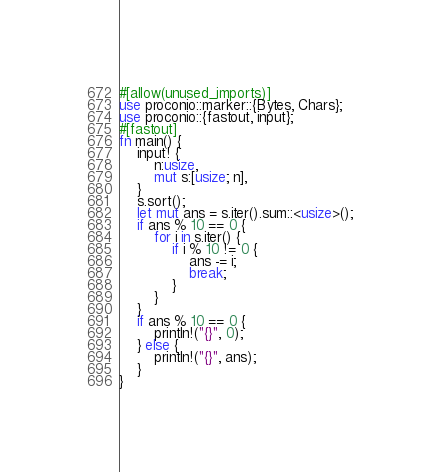<code> <loc_0><loc_0><loc_500><loc_500><_Rust_>#[allow(unused_imports)]
use proconio::marker::{Bytes, Chars};
use proconio::{fastout, input};
#[fastout]
fn main() {
    input! {
        n:usize,
        mut s:[usize; n],
    }
    s.sort();
    let mut ans = s.iter().sum::<usize>();
    if ans % 10 == 0 {
        for i in s.iter() {
            if i % 10 != 0 {
                ans -= i;
                break;
            }
        }
    }
    if ans % 10 == 0 {
        println!("{}", 0);
    } else {
        println!("{}", ans);
    }
}
</code> 